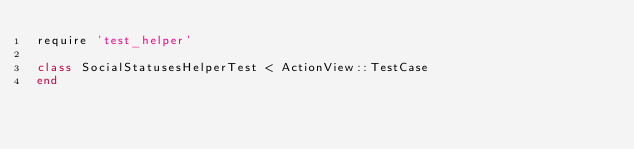Convert code to text. <code><loc_0><loc_0><loc_500><loc_500><_Ruby_>require 'test_helper'

class SocialStatusesHelperTest < ActionView::TestCase
end
</code> 